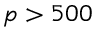Convert formula to latex. <formula><loc_0><loc_0><loc_500><loc_500>p > 5 0 0</formula> 